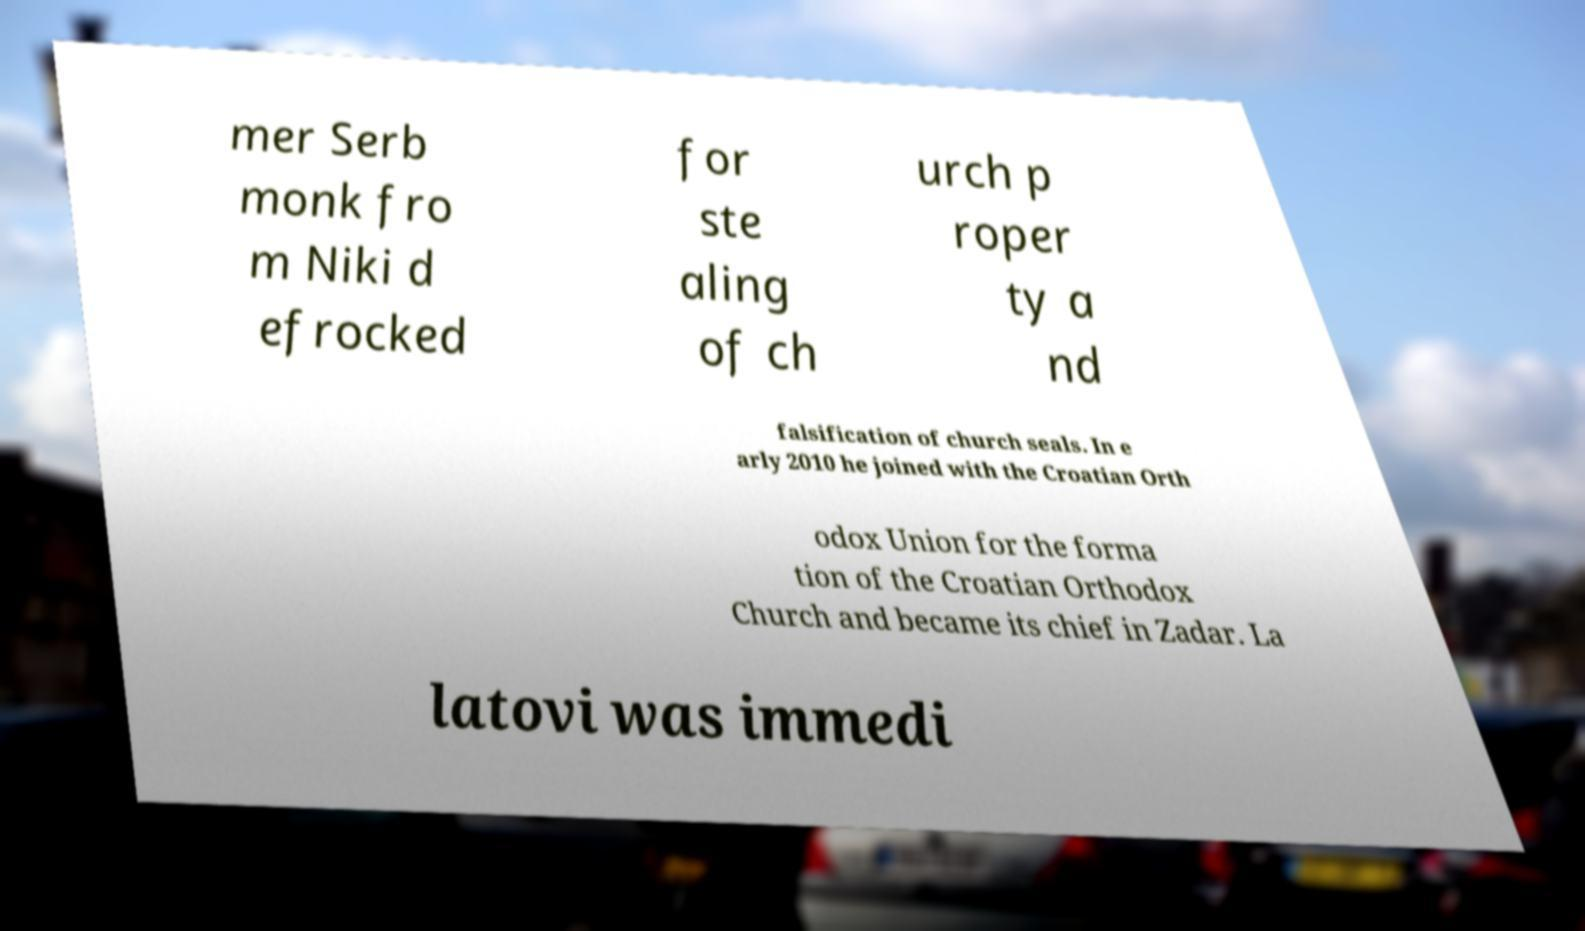What messages or text are displayed in this image? I need them in a readable, typed format. mer Serb monk fro m Niki d efrocked for ste aling of ch urch p roper ty a nd falsification of church seals. In e arly 2010 he joined with the Croatian Orth odox Union for the forma tion of the Croatian Orthodox Church and became its chief in Zadar. La latovi was immedi 